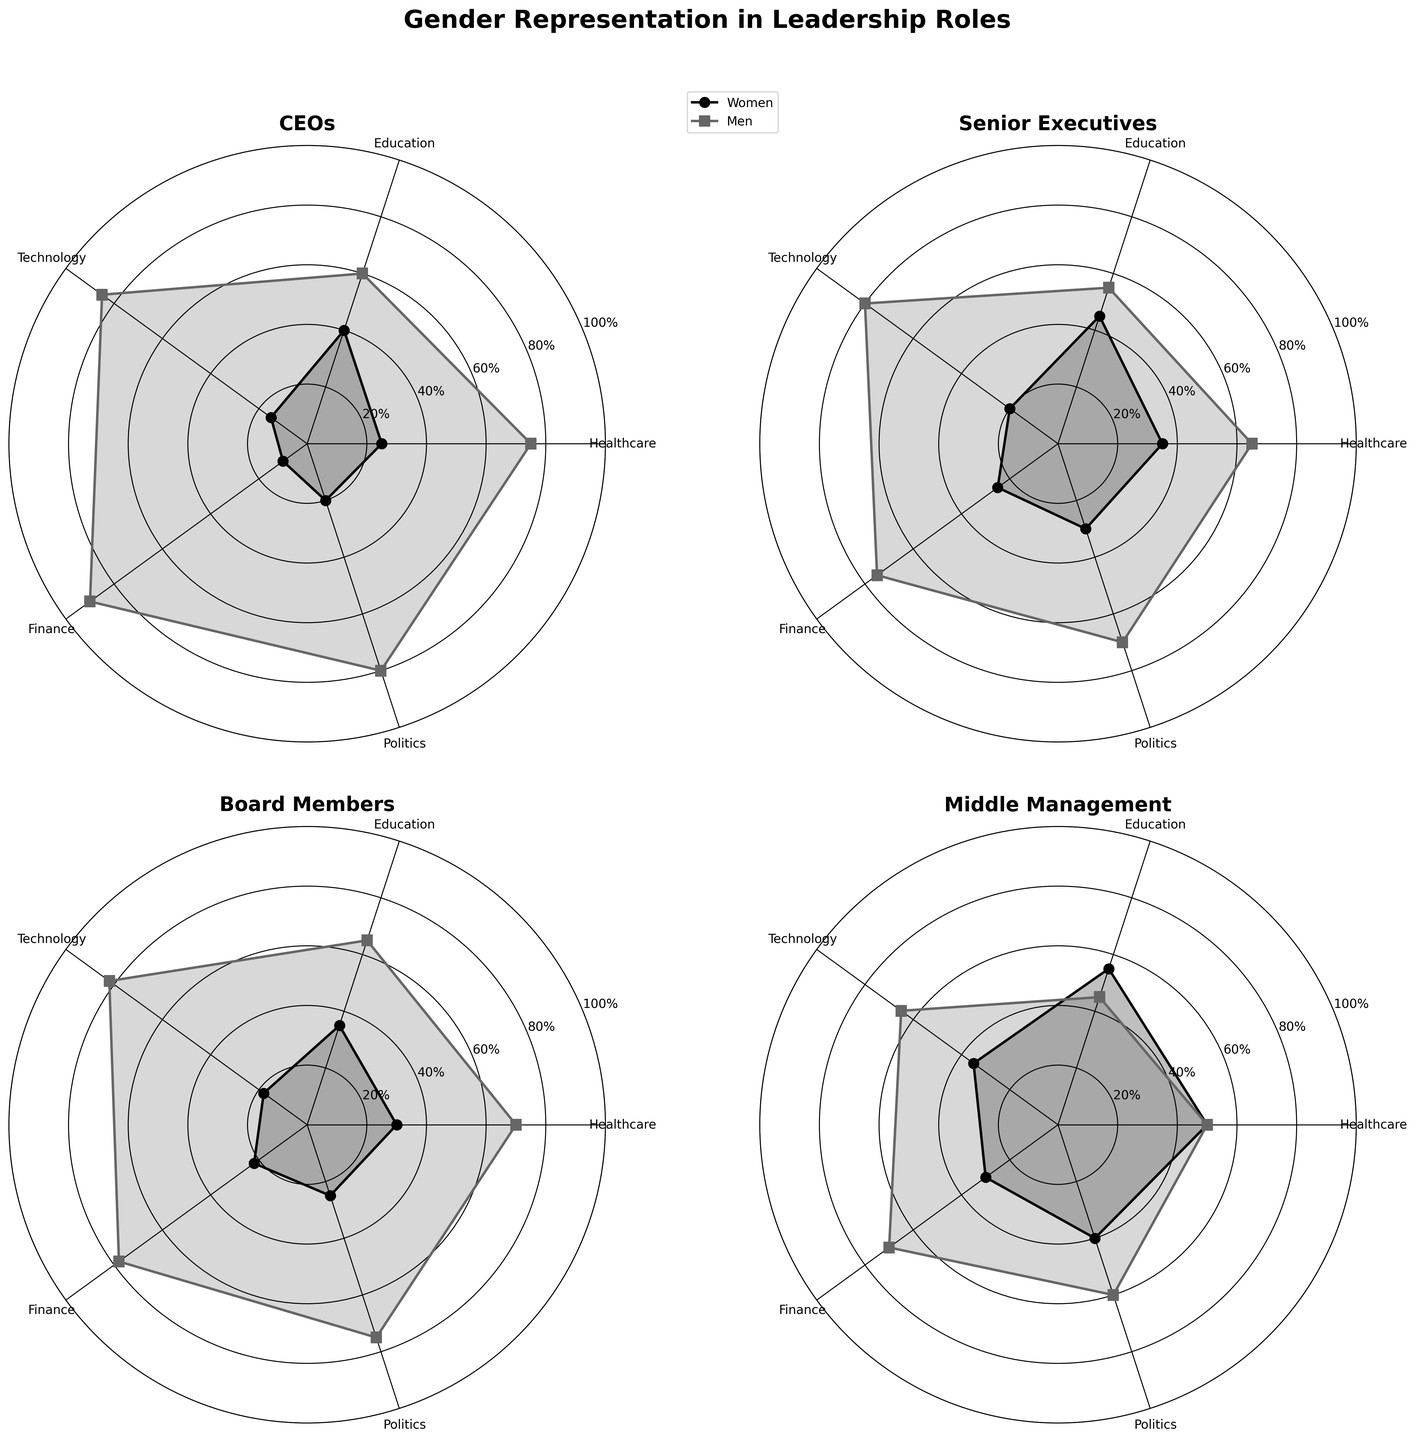What is the title of the figure? The title of the figure is displayed at the top of the chart, which summarizes the overall content and purpose of the figure.
Answer: Gender Representation in Leadership Roles Which sector has the highest percentage of women CEOs? By comparing the section for women CEOs across all sectors, the sector with the highest percentage is visually the highest point among all sectors.
Answer: Education In which sector is the difference between men and women Senior Executives the smallest? The difference is smallest where the lines for men and women Senior Executives are closest. By comparing the gap between the two lines for all sectors, the smallest difference can be observed.
Answer: Education What is the range of values for men in Board Members across all sectors? The range can be determined by finding the minimum and maximum percentages for men Board Members in all sectors. Read the radar chart values for men in Board Members.
Answer: 65% to 82% How do the percentages of men and women in Middle Management in Technology compare? For Technology, locate the points representing men and women in Middle Management. Compare their positions to determine if one is higher.
Answer: Men 65%, Women 35% What is the average percentage of women across all sectors in Entry Level Positions? Add the percentages of women in Entry Level Positions across all sectors and divide by the number of sectors.
Answer: (60 + 70 + 50 + 45 + 55) / 5 = 56% Which leadership role shows the least gender disparity across all sectors? Examine all subplots and identify the role where the lines for men and women are closest overall.
Answer: Entry Level Positions In the Finance sector, which role has the highest percentage of women? Look at the values for the Finance sector across all roles and find the highest percentage for women.
Answer: Entry Level Positions How does the percentage of women in Politics as Board Members compare to their representation as Senior Executives? Compare the data points for Politics on both the Board Members radar chart and the Senior Executives radar chart, specifically the women’s values.
Answer: Women Board Members 25%, Women Senior Executives 30% Which sector has the greatest disparity between men and women CEOs? Identify the sector with the largest difference in percentage between men and women CEOs by comparing the lengths of the lines.
Answer: Technology 